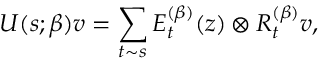<formula> <loc_0><loc_0><loc_500><loc_500>U ( s ; \beta ) v = \sum _ { t \sim s } E _ { t } ^ { ( \beta ) } ( z ) \otimes R _ { t } ^ { ( \beta ) } v ,</formula> 